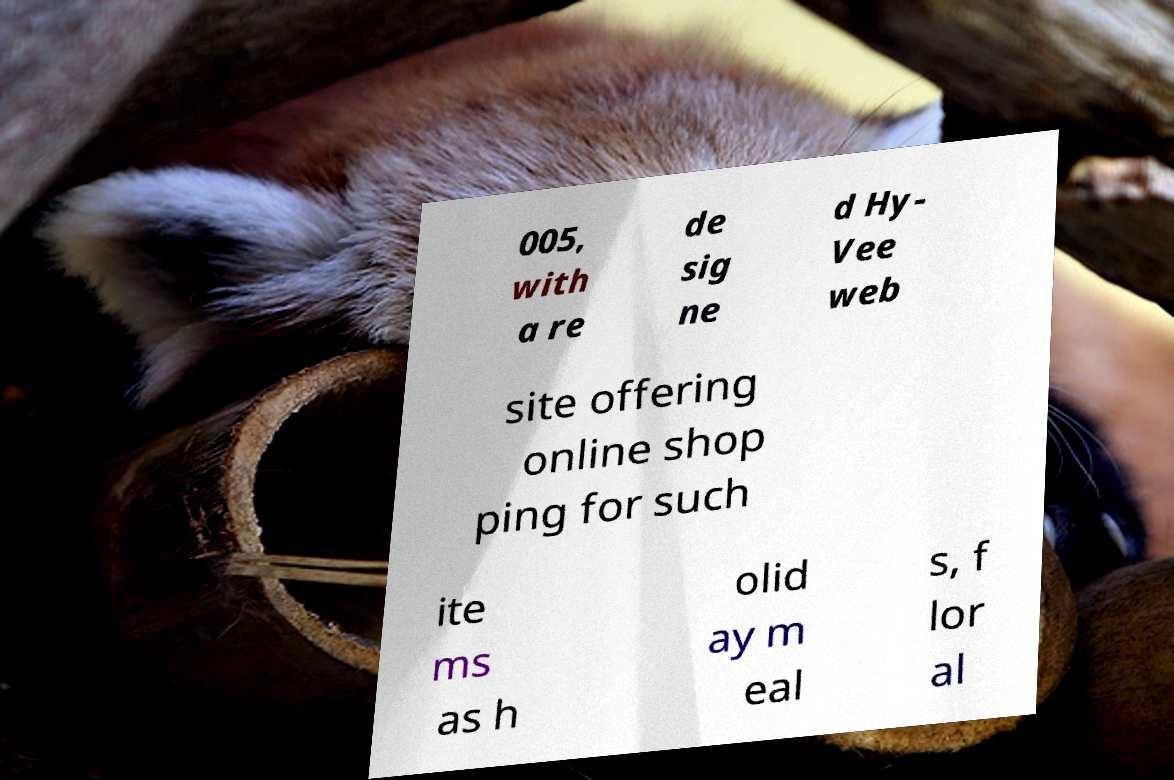Could you extract and type out the text from this image? 005, with a re de sig ne d Hy- Vee web site offering online shop ping for such ite ms as h olid ay m eal s, f lor al 